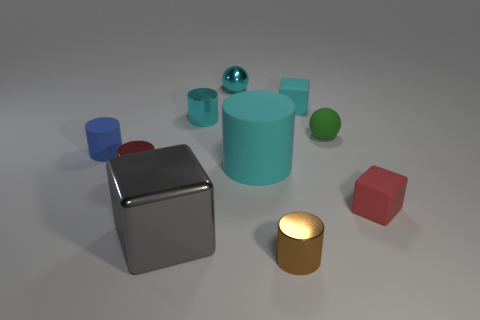There is a matte object left of the large cylinder; is it the same shape as the small brown thing?
Make the answer very short. Yes. Is the number of red objects less than the number of tiny objects?
Your response must be concise. Yes. Is there any other thing that is the same color as the tiny metal ball?
Provide a succinct answer. Yes. The cyan metallic thing that is to the left of the cyan sphere has what shape?
Make the answer very short. Cylinder. There is a small metal sphere; does it have the same color as the small cylinder that is behind the blue cylinder?
Keep it short and to the point. Yes. Is the number of blocks that are to the left of the shiny sphere the same as the number of gray blocks that are behind the tiny red shiny cylinder?
Make the answer very short. No. What number of other objects are there of the same size as the green matte ball?
Ensure brevity in your answer.  7. The gray shiny thing has what size?
Keep it short and to the point. Large. Is the material of the big gray cube the same as the cyan thing that is right of the large cyan rubber object?
Offer a terse response. No. Are there any other objects of the same shape as the green matte object?
Your answer should be very brief. Yes. 